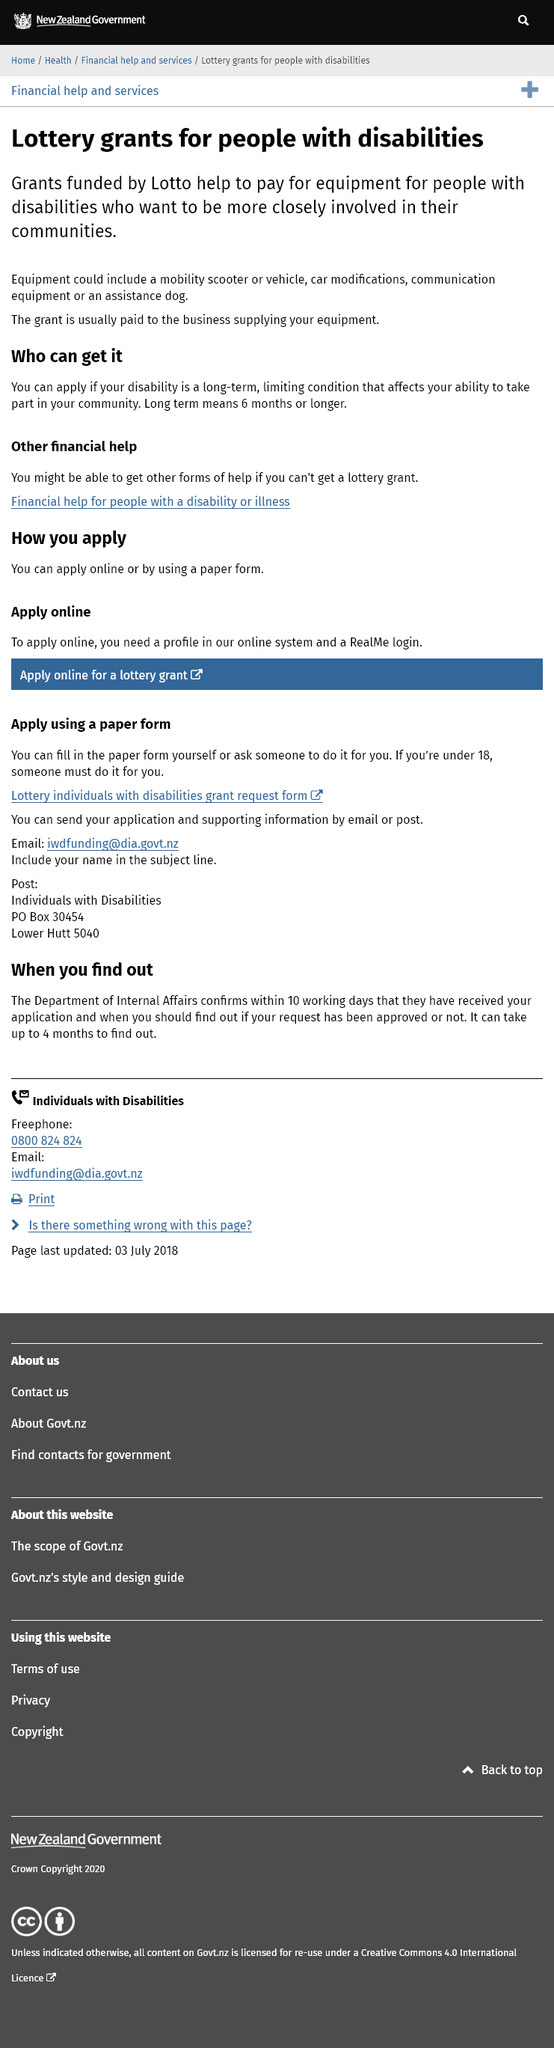Identify some key points in this picture. The grant is typically awarded to the business that provides the equipment. The grant is intended for individuals with disabilities. According to the information presented above, 'long term' means six months or longer. 